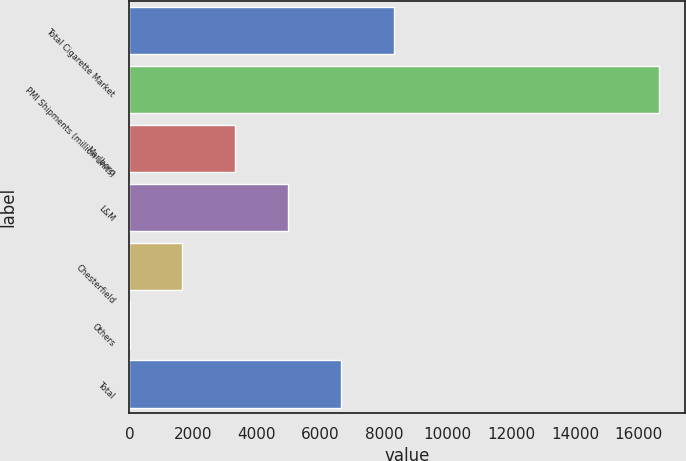<chart> <loc_0><loc_0><loc_500><loc_500><bar_chart><fcel>Total Cigarette Market<fcel>PMI Shipments (million units)<fcel>Marlboro<fcel>L&M<fcel>Chesterfield<fcel>Others<fcel>Total<nl><fcel>8316.55<fcel>16630<fcel>3328.48<fcel>4991.17<fcel>1665.79<fcel>3.1<fcel>6653.86<nl></chart> 